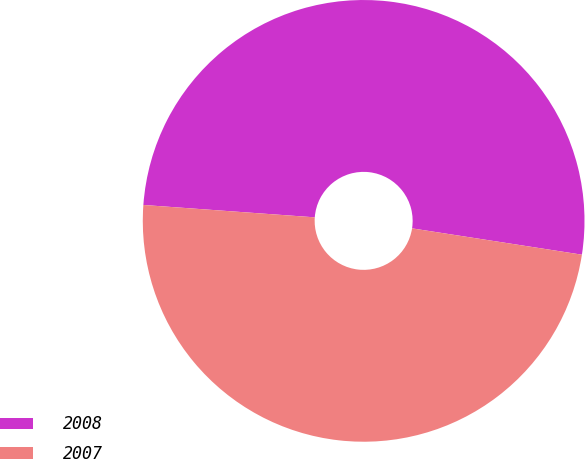Convert chart to OTSL. <chart><loc_0><loc_0><loc_500><loc_500><pie_chart><fcel>2008<fcel>2007<nl><fcel>51.3%<fcel>48.7%<nl></chart> 